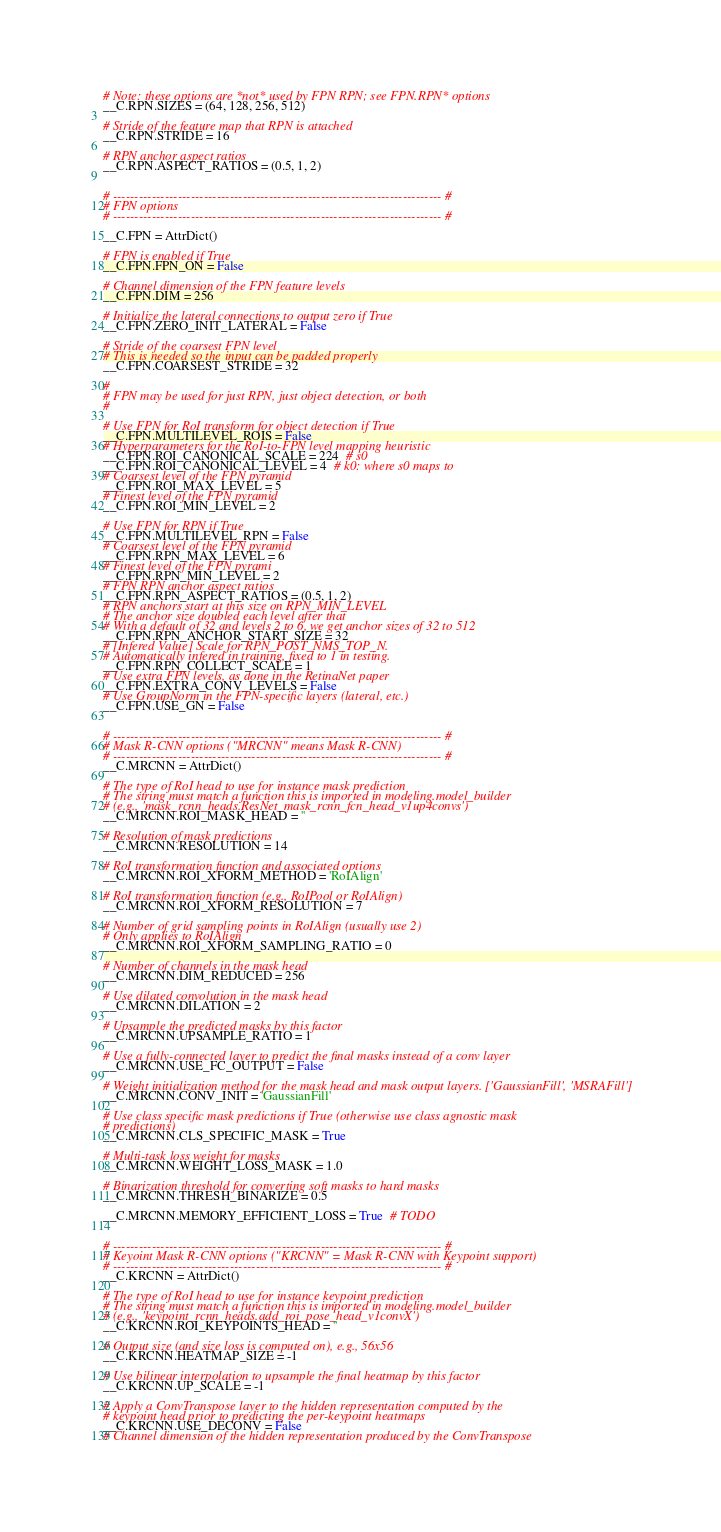Convert code to text. <code><loc_0><loc_0><loc_500><loc_500><_Python_># Note: these options are *not* used by FPN RPN; see FPN.RPN* options
__C.RPN.SIZES = (64, 128, 256, 512)

# Stride of the feature map that RPN is attached
__C.RPN.STRIDE = 16

# RPN anchor aspect ratios
__C.RPN.ASPECT_RATIOS = (0.5, 1, 2)


# ---------------------------------------------------------------------------- #
# FPN options
# ---------------------------------------------------------------------------- #

__C.FPN = AttrDict()

# FPN is enabled if True
__C.FPN.FPN_ON = False

# Channel dimension of the FPN feature levels
__C.FPN.DIM = 256

# Initialize the lateral connections to output zero if True
__C.FPN.ZERO_INIT_LATERAL = False

# Stride of the coarsest FPN level
# This is needed so the input can be padded properly
__C.FPN.COARSEST_STRIDE = 32

#
# FPN may be used for just RPN, just object detection, or both
#

# Use FPN for RoI transform for object detection if True
__C.FPN.MULTILEVEL_ROIS = False
# Hyperparameters for the RoI-to-FPN level mapping heuristic
__C.FPN.ROI_CANONICAL_SCALE = 224  # s0
__C.FPN.ROI_CANONICAL_LEVEL = 4  # k0: where s0 maps to
# Coarsest level of the FPN pyramid
__C.FPN.ROI_MAX_LEVEL = 5
# Finest level of the FPN pyramid
__C.FPN.ROI_MIN_LEVEL = 2

# Use FPN for RPN if True
__C.FPN.MULTILEVEL_RPN = False
# Coarsest level of the FPN pyramid
__C.FPN.RPN_MAX_LEVEL = 6
# Finest level of the FPN pyrami
__C.FPN.RPN_MIN_LEVEL = 2
# FPN RPN anchor aspect ratios
__C.FPN.RPN_ASPECT_RATIOS = (0.5, 1, 2)
# RPN anchors start at this size on RPN_MIN_LEVEL
# The anchor size doubled each level after that
# With a default of 32 and levels 2 to 6, we get anchor sizes of 32 to 512
__C.FPN.RPN_ANCHOR_START_SIZE = 32
# [Infered Value] Scale for RPN_POST_NMS_TOP_N.
# Automatically infered in training, fixed to 1 in testing.
__C.FPN.RPN_COLLECT_SCALE = 1
# Use extra FPN levels, as done in the RetinaNet paper
__C.FPN.EXTRA_CONV_LEVELS = False
# Use GroupNorm in the FPN-specific layers (lateral, etc.)
__C.FPN.USE_GN = False


# ---------------------------------------------------------------------------- #
# Mask R-CNN options ("MRCNN" means Mask R-CNN)
# ---------------------------------------------------------------------------- #
__C.MRCNN = AttrDict()

# The type of RoI head to use for instance mask prediction
# The string must match a function this is imported in modeling.model_builder
# (e.g., 'mask_rcnn_heads.ResNet_mask_rcnn_fcn_head_v1up4convs')
__C.MRCNN.ROI_MASK_HEAD = ''

# Resolution of mask predictions
__C.MRCNN.RESOLUTION = 14

# RoI transformation function and associated options
__C.MRCNN.ROI_XFORM_METHOD = 'RoIAlign'

# RoI transformation function (e.g., RoIPool or RoIAlign)
__C.MRCNN.ROI_XFORM_RESOLUTION = 7

# Number of grid sampling points in RoIAlign (usually use 2)
# Only applies to RoIAlign
__C.MRCNN.ROI_XFORM_SAMPLING_RATIO = 0

# Number of channels in the mask head
__C.MRCNN.DIM_REDUCED = 256

# Use dilated convolution in the mask head
__C.MRCNN.DILATION = 2

# Upsample the predicted masks by this factor
__C.MRCNN.UPSAMPLE_RATIO = 1

# Use a fully-connected layer to predict the final masks instead of a conv layer
__C.MRCNN.USE_FC_OUTPUT = False

# Weight initialization method for the mask head and mask output layers. ['GaussianFill', 'MSRAFill']
__C.MRCNN.CONV_INIT = 'GaussianFill'

# Use class specific mask predictions if True (otherwise use class agnostic mask
# predictions)
__C.MRCNN.CLS_SPECIFIC_MASK = True

# Multi-task loss weight for masks
__C.MRCNN.WEIGHT_LOSS_MASK = 1.0

# Binarization threshold for converting soft masks to hard masks
__C.MRCNN.THRESH_BINARIZE = 0.5

__C.MRCNN.MEMORY_EFFICIENT_LOSS = True  # TODO


# ---------------------------------------------------------------------------- #
# Keyoint Mask R-CNN options ("KRCNN" = Mask R-CNN with Keypoint support)
# ---------------------------------------------------------------------------- #
__C.KRCNN = AttrDict()

# The type of RoI head to use for instance keypoint prediction
# The string must match a function this is imported in modeling.model_builder
# (e.g., 'keypoint_rcnn_heads.add_roi_pose_head_v1convX')
__C.KRCNN.ROI_KEYPOINTS_HEAD = ''

# Output size (and size loss is computed on), e.g., 56x56
__C.KRCNN.HEATMAP_SIZE = -1

# Use bilinear interpolation to upsample the final heatmap by this factor
__C.KRCNN.UP_SCALE = -1

# Apply a ConvTranspose layer to the hidden representation computed by the
# keypoint head prior to predicting the per-keypoint heatmaps
__C.KRCNN.USE_DECONV = False
# Channel dimension of the hidden representation produced by the ConvTranspose</code> 